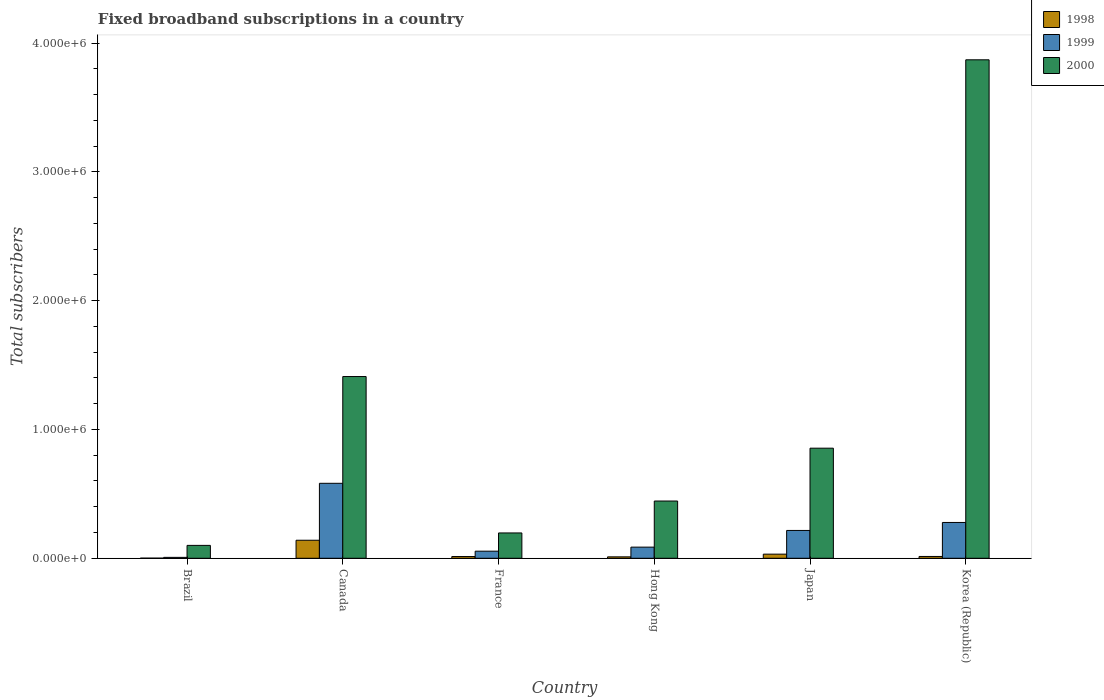How many different coloured bars are there?
Offer a terse response. 3. Are the number of bars per tick equal to the number of legend labels?
Provide a succinct answer. Yes. What is the label of the 1st group of bars from the left?
Offer a very short reply. Brazil. In how many cases, is the number of bars for a given country not equal to the number of legend labels?
Make the answer very short. 0. What is the number of broadband subscriptions in 2000 in Brazil?
Keep it short and to the point. 1.00e+05. Across all countries, what is the maximum number of broadband subscriptions in 1998?
Ensure brevity in your answer.  1.40e+05. What is the total number of broadband subscriptions in 2000 in the graph?
Make the answer very short. 6.88e+06. What is the difference between the number of broadband subscriptions in 1998 in Hong Kong and that in Korea (Republic)?
Your response must be concise. -3000. What is the difference between the number of broadband subscriptions in 2000 in Brazil and the number of broadband subscriptions in 1998 in Hong Kong?
Your answer should be compact. 8.90e+04. What is the average number of broadband subscriptions in 1998 per country?
Provide a short and direct response. 3.52e+04. What is the difference between the number of broadband subscriptions of/in 1999 and number of broadband subscriptions of/in 2000 in Brazil?
Keep it short and to the point. -9.30e+04. What is the ratio of the number of broadband subscriptions in 1998 in Canada to that in France?
Provide a succinct answer. 10.4. Is the number of broadband subscriptions in 1999 in Brazil less than that in Korea (Republic)?
Give a very brief answer. Yes. Is the difference between the number of broadband subscriptions in 1999 in Brazil and Korea (Republic) greater than the difference between the number of broadband subscriptions in 2000 in Brazil and Korea (Republic)?
Offer a very short reply. Yes. What is the difference between the highest and the second highest number of broadband subscriptions in 2000?
Your answer should be compact. 2.46e+06. What is the difference between the highest and the lowest number of broadband subscriptions in 1998?
Provide a succinct answer. 1.39e+05. In how many countries, is the number of broadband subscriptions in 1998 greater than the average number of broadband subscriptions in 1998 taken over all countries?
Your answer should be compact. 1. Is the sum of the number of broadband subscriptions in 1999 in France and Korea (Republic) greater than the maximum number of broadband subscriptions in 2000 across all countries?
Your answer should be compact. No. What does the 1st bar from the right in Japan represents?
Give a very brief answer. 2000. Are all the bars in the graph horizontal?
Give a very brief answer. No. How many countries are there in the graph?
Ensure brevity in your answer.  6. What is the difference between two consecutive major ticks on the Y-axis?
Your answer should be very brief. 1.00e+06. Where does the legend appear in the graph?
Your answer should be compact. Top right. How many legend labels are there?
Offer a very short reply. 3. How are the legend labels stacked?
Offer a terse response. Vertical. What is the title of the graph?
Offer a terse response. Fixed broadband subscriptions in a country. What is the label or title of the Y-axis?
Ensure brevity in your answer.  Total subscribers. What is the Total subscribers of 1998 in Brazil?
Give a very brief answer. 1000. What is the Total subscribers in 1999 in Brazil?
Your answer should be compact. 7000. What is the Total subscribers in 2000 in Brazil?
Provide a short and direct response. 1.00e+05. What is the Total subscribers of 1999 in Canada?
Ensure brevity in your answer.  5.82e+05. What is the Total subscribers of 2000 in Canada?
Keep it short and to the point. 1.41e+06. What is the Total subscribers in 1998 in France?
Ensure brevity in your answer.  1.35e+04. What is the Total subscribers of 1999 in France?
Your answer should be compact. 5.50e+04. What is the Total subscribers in 2000 in France?
Ensure brevity in your answer.  1.97e+05. What is the Total subscribers of 1998 in Hong Kong?
Ensure brevity in your answer.  1.10e+04. What is the Total subscribers of 1999 in Hong Kong?
Provide a succinct answer. 8.65e+04. What is the Total subscribers in 2000 in Hong Kong?
Provide a succinct answer. 4.44e+05. What is the Total subscribers in 1998 in Japan?
Ensure brevity in your answer.  3.20e+04. What is the Total subscribers in 1999 in Japan?
Your answer should be very brief. 2.16e+05. What is the Total subscribers of 2000 in Japan?
Provide a short and direct response. 8.55e+05. What is the Total subscribers of 1998 in Korea (Republic)?
Offer a terse response. 1.40e+04. What is the Total subscribers in 1999 in Korea (Republic)?
Give a very brief answer. 2.78e+05. What is the Total subscribers of 2000 in Korea (Republic)?
Your answer should be very brief. 3.87e+06. Across all countries, what is the maximum Total subscribers in 1998?
Your answer should be compact. 1.40e+05. Across all countries, what is the maximum Total subscribers of 1999?
Keep it short and to the point. 5.82e+05. Across all countries, what is the maximum Total subscribers of 2000?
Your response must be concise. 3.87e+06. Across all countries, what is the minimum Total subscribers in 1999?
Provide a short and direct response. 7000. What is the total Total subscribers in 1998 in the graph?
Your answer should be compact. 2.11e+05. What is the total Total subscribers in 1999 in the graph?
Your response must be concise. 1.22e+06. What is the total Total subscribers in 2000 in the graph?
Your answer should be compact. 6.88e+06. What is the difference between the Total subscribers in 1998 in Brazil and that in Canada?
Keep it short and to the point. -1.39e+05. What is the difference between the Total subscribers in 1999 in Brazil and that in Canada?
Ensure brevity in your answer.  -5.75e+05. What is the difference between the Total subscribers of 2000 in Brazil and that in Canada?
Offer a terse response. -1.31e+06. What is the difference between the Total subscribers in 1998 in Brazil and that in France?
Provide a short and direct response. -1.25e+04. What is the difference between the Total subscribers of 1999 in Brazil and that in France?
Provide a short and direct response. -4.80e+04. What is the difference between the Total subscribers of 2000 in Brazil and that in France?
Give a very brief answer. -9.66e+04. What is the difference between the Total subscribers in 1999 in Brazil and that in Hong Kong?
Offer a terse response. -7.95e+04. What is the difference between the Total subscribers in 2000 in Brazil and that in Hong Kong?
Offer a very short reply. -3.44e+05. What is the difference between the Total subscribers in 1998 in Brazil and that in Japan?
Provide a succinct answer. -3.10e+04. What is the difference between the Total subscribers in 1999 in Brazil and that in Japan?
Keep it short and to the point. -2.09e+05. What is the difference between the Total subscribers of 2000 in Brazil and that in Japan?
Your response must be concise. -7.55e+05. What is the difference between the Total subscribers of 1998 in Brazil and that in Korea (Republic)?
Give a very brief answer. -1.30e+04. What is the difference between the Total subscribers in 1999 in Brazil and that in Korea (Republic)?
Your response must be concise. -2.71e+05. What is the difference between the Total subscribers of 2000 in Brazil and that in Korea (Republic)?
Your response must be concise. -3.77e+06. What is the difference between the Total subscribers of 1998 in Canada and that in France?
Your answer should be compact. 1.27e+05. What is the difference between the Total subscribers of 1999 in Canada and that in France?
Offer a terse response. 5.27e+05. What is the difference between the Total subscribers in 2000 in Canada and that in France?
Give a very brief answer. 1.21e+06. What is the difference between the Total subscribers in 1998 in Canada and that in Hong Kong?
Your answer should be very brief. 1.29e+05. What is the difference between the Total subscribers in 1999 in Canada and that in Hong Kong?
Your response must be concise. 4.96e+05. What is the difference between the Total subscribers of 2000 in Canada and that in Hong Kong?
Keep it short and to the point. 9.66e+05. What is the difference between the Total subscribers in 1998 in Canada and that in Japan?
Your response must be concise. 1.08e+05. What is the difference between the Total subscribers of 1999 in Canada and that in Japan?
Provide a short and direct response. 3.66e+05. What is the difference between the Total subscribers of 2000 in Canada and that in Japan?
Ensure brevity in your answer.  5.56e+05. What is the difference between the Total subscribers in 1998 in Canada and that in Korea (Republic)?
Provide a succinct answer. 1.26e+05. What is the difference between the Total subscribers in 1999 in Canada and that in Korea (Republic)?
Make the answer very short. 3.04e+05. What is the difference between the Total subscribers in 2000 in Canada and that in Korea (Republic)?
Provide a succinct answer. -2.46e+06. What is the difference between the Total subscribers in 1998 in France and that in Hong Kong?
Keep it short and to the point. 2464. What is the difference between the Total subscribers of 1999 in France and that in Hong Kong?
Your answer should be compact. -3.15e+04. What is the difference between the Total subscribers in 2000 in France and that in Hong Kong?
Provide a short and direct response. -2.48e+05. What is the difference between the Total subscribers in 1998 in France and that in Japan?
Your response must be concise. -1.85e+04. What is the difference between the Total subscribers of 1999 in France and that in Japan?
Your answer should be compact. -1.61e+05. What is the difference between the Total subscribers in 2000 in France and that in Japan?
Give a very brief answer. -6.58e+05. What is the difference between the Total subscribers of 1998 in France and that in Korea (Republic)?
Offer a terse response. -536. What is the difference between the Total subscribers of 1999 in France and that in Korea (Republic)?
Provide a short and direct response. -2.23e+05. What is the difference between the Total subscribers in 2000 in France and that in Korea (Republic)?
Give a very brief answer. -3.67e+06. What is the difference between the Total subscribers in 1998 in Hong Kong and that in Japan?
Offer a very short reply. -2.10e+04. What is the difference between the Total subscribers of 1999 in Hong Kong and that in Japan?
Your answer should be compact. -1.30e+05. What is the difference between the Total subscribers in 2000 in Hong Kong and that in Japan?
Ensure brevity in your answer.  -4.10e+05. What is the difference between the Total subscribers of 1998 in Hong Kong and that in Korea (Republic)?
Keep it short and to the point. -3000. What is the difference between the Total subscribers of 1999 in Hong Kong and that in Korea (Republic)?
Your answer should be very brief. -1.92e+05. What is the difference between the Total subscribers of 2000 in Hong Kong and that in Korea (Republic)?
Your answer should be compact. -3.43e+06. What is the difference between the Total subscribers of 1998 in Japan and that in Korea (Republic)?
Your answer should be compact. 1.80e+04. What is the difference between the Total subscribers in 1999 in Japan and that in Korea (Republic)?
Ensure brevity in your answer.  -6.20e+04. What is the difference between the Total subscribers in 2000 in Japan and that in Korea (Republic)?
Ensure brevity in your answer.  -3.02e+06. What is the difference between the Total subscribers in 1998 in Brazil and the Total subscribers in 1999 in Canada?
Ensure brevity in your answer.  -5.81e+05. What is the difference between the Total subscribers in 1998 in Brazil and the Total subscribers in 2000 in Canada?
Make the answer very short. -1.41e+06. What is the difference between the Total subscribers of 1999 in Brazil and the Total subscribers of 2000 in Canada?
Your response must be concise. -1.40e+06. What is the difference between the Total subscribers in 1998 in Brazil and the Total subscribers in 1999 in France?
Your answer should be very brief. -5.40e+04. What is the difference between the Total subscribers of 1998 in Brazil and the Total subscribers of 2000 in France?
Your answer should be very brief. -1.96e+05. What is the difference between the Total subscribers in 1999 in Brazil and the Total subscribers in 2000 in France?
Offer a very short reply. -1.90e+05. What is the difference between the Total subscribers in 1998 in Brazil and the Total subscribers in 1999 in Hong Kong?
Keep it short and to the point. -8.55e+04. What is the difference between the Total subscribers of 1998 in Brazil and the Total subscribers of 2000 in Hong Kong?
Offer a very short reply. -4.43e+05. What is the difference between the Total subscribers in 1999 in Brazil and the Total subscribers in 2000 in Hong Kong?
Your answer should be compact. -4.37e+05. What is the difference between the Total subscribers of 1998 in Brazil and the Total subscribers of 1999 in Japan?
Ensure brevity in your answer.  -2.15e+05. What is the difference between the Total subscribers of 1998 in Brazil and the Total subscribers of 2000 in Japan?
Offer a terse response. -8.54e+05. What is the difference between the Total subscribers of 1999 in Brazil and the Total subscribers of 2000 in Japan?
Provide a short and direct response. -8.48e+05. What is the difference between the Total subscribers of 1998 in Brazil and the Total subscribers of 1999 in Korea (Republic)?
Make the answer very short. -2.77e+05. What is the difference between the Total subscribers in 1998 in Brazil and the Total subscribers in 2000 in Korea (Republic)?
Make the answer very short. -3.87e+06. What is the difference between the Total subscribers of 1999 in Brazil and the Total subscribers of 2000 in Korea (Republic)?
Offer a terse response. -3.86e+06. What is the difference between the Total subscribers in 1998 in Canada and the Total subscribers in 1999 in France?
Offer a very short reply. 8.50e+04. What is the difference between the Total subscribers in 1998 in Canada and the Total subscribers in 2000 in France?
Your response must be concise. -5.66e+04. What is the difference between the Total subscribers of 1999 in Canada and the Total subscribers of 2000 in France?
Offer a very short reply. 3.85e+05. What is the difference between the Total subscribers in 1998 in Canada and the Total subscribers in 1999 in Hong Kong?
Your answer should be compact. 5.35e+04. What is the difference between the Total subscribers in 1998 in Canada and the Total subscribers in 2000 in Hong Kong?
Your answer should be compact. -3.04e+05. What is the difference between the Total subscribers in 1999 in Canada and the Total subscribers in 2000 in Hong Kong?
Offer a very short reply. 1.38e+05. What is the difference between the Total subscribers in 1998 in Canada and the Total subscribers in 1999 in Japan?
Offer a very short reply. -7.60e+04. What is the difference between the Total subscribers of 1998 in Canada and the Total subscribers of 2000 in Japan?
Keep it short and to the point. -7.15e+05. What is the difference between the Total subscribers in 1999 in Canada and the Total subscribers in 2000 in Japan?
Provide a short and direct response. -2.73e+05. What is the difference between the Total subscribers in 1998 in Canada and the Total subscribers in 1999 in Korea (Republic)?
Offer a very short reply. -1.38e+05. What is the difference between the Total subscribers of 1998 in Canada and the Total subscribers of 2000 in Korea (Republic)?
Provide a succinct answer. -3.73e+06. What is the difference between the Total subscribers of 1999 in Canada and the Total subscribers of 2000 in Korea (Republic)?
Provide a succinct answer. -3.29e+06. What is the difference between the Total subscribers in 1998 in France and the Total subscribers in 1999 in Hong Kong?
Ensure brevity in your answer.  -7.30e+04. What is the difference between the Total subscribers of 1998 in France and the Total subscribers of 2000 in Hong Kong?
Give a very brief answer. -4.31e+05. What is the difference between the Total subscribers of 1999 in France and the Total subscribers of 2000 in Hong Kong?
Give a very brief answer. -3.89e+05. What is the difference between the Total subscribers in 1998 in France and the Total subscribers in 1999 in Japan?
Offer a very short reply. -2.03e+05. What is the difference between the Total subscribers in 1998 in France and the Total subscribers in 2000 in Japan?
Keep it short and to the point. -8.41e+05. What is the difference between the Total subscribers of 1999 in France and the Total subscribers of 2000 in Japan?
Provide a short and direct response. -8.00e+05. What is the difference between the Total subscribers in 1998 in France and the Total subscribers in 1999 in Korea (Republic)?
Your response must be concise. -2.65e+05. What is the difference between the Total subscribers of 1998 in France and the Total subscribers of 2000 in Korea (Republic)?
Make the answer very short. -3.86e+06. What is the difference between the Total subscribers of 1999 in France and the Total subscribers of 2000 in Korea (Republic)?
Offer a very short reply. -3.82e+06. What is the difference between the Total subscribers of 1998 in Hong Kong and the Total subscribers of 1999 in Japan?
Offer a very short reply. -2.05e+05. What is the difference between the Total subscribers in 1998 in Hong Kong and the Total subscribers in 2000 in Japan?
Provide a succinct answer. -8.44e+05. What is the difference between the Total subscribers in 1999 in Hong Kong and the Total subscribers in 2000 in Japan?
Make the answer very short. -7.68e+05. What is the difference between the Total subscribers in 1998 in Hong Kong and the Total subscribers in 1999 in Korea (Republic)?
Make the answer very short. -2.67e+05. What is the difference between the Total subscribers in 1998 in Hong Kong and the Total subscribers in 2000 in Korea (Republic)?
Give a very brief answer. -3.86e+06. What is the difference between the Total subscribers in 1999 in Hong Kong and the Total subscribers in 2000 in Korea (Republic)?
Your response must be concise. -3.78e+06. What is the difference between the Total subscribers in 1998 in Japan and the Total subscribers in 1999 in Korea (Republic)?
Keep it short and to the point. -2.46e+05. What is the difference between the Total subscribers of 1998 in Japan and the Total subscribers of 2000 in Korea (Republic)?
Keep it short and to the point. -3.84e+06. What is the difference between the Total subscribers in 1999 in Japan and the Total subscribers in 2000 in Korea (Republic)?
Keep it short and to the point. -3.65e+06. What is the average Total subscribers in 1998 per country?
Offer a very short reply. 3.52e+04. What is the average Total subscribers of 1999 per country?
Provide a succinct answer. 2.04e+05. What is the average Total subscribers in 2000 per country?
Offer a terse response. 1.15e+06. What is the difference between the Total subscribers in 1998 and Total subscribers in 1999 in Brazil?
Ensure brevity in your answer.  -6000. What is the difference between the Total subscribers of 1998 and Total subscribers of 2000 in Brazil?
Keep it short and to the point. -9.90e+04. What is the difference between the Total subscribers of 1999 and Total subscribers of 2000 in Brazil?
Ensure brevity in your answer.  -9.30e+04. What is the difference between the Total subscribers of 1998 and Total subscribers of 1999 in Canada?
Provide a short and direct response. -4.42e+05. What is the difference between the Total subscribers of 1998 and Total subscribers of 2000 in Canada?
Keep it short and to the point. -1.27e+06. What is the difference between the Total subscribers of 1999 and Total subscribers of 2000 in Canada?
Offer a very short reply. -8.29e+05. What is the difference between the Total subscribers of 1998 and Total subscribers of 1999 in France?
Provide a succinct answer. -4.15e+04. What is the difference between the Total subscribers in 1998 and Total subscribers in 2000 in France?
Give a very brief answer. -1.83e+05. What is the difference between the Total subscribers of 1999 and Total subscribers of 2000 in France?
Provide a short and direct response. -1.42e+05. What is the difference between the Total subscribers of 1998 and Total subscribers of 1999 in Hong Kong?
Provide a short and direct response. -7.55e+04. What is the difference between the Total subscribers in 1998 and Total subscribers in 2000 in Hong Kong?
Your answer should be very brief. -4.33e+05. What is the difference between the Total subscribers of 1999 and Total subscribers of 2000 in Hong Kong?
Make the answer very short. -3.58e+05. What is the difference between the Total subscribers of 1998 and Total subscribers of 1999 in Japan?
Ensure brevity in your answer.  -1.84e+05. What is the difference between the Total subscribers in 1998 and Total subscribers in 2000 in Japan?
Give a very brief answer. -8.23e+05. What is the difference between the Total subscribers in 1999 and Total subscribers in 2000 in Japan?
Ensure brevity in your answer.  -6.39e+05. What is the difference between the Total subscribers in 1998 and Total subscribers in 1999 in Korea (Republic)?
Make the answer very short. -2.64e+05. What is the difference between the Total subscribers of 1998 and Total subscribers of 2000 in Korea (Republic)?
Your answer should be compact. -3.86e+06. What is the difference between the Total subscribers of 1999 and Total subscribers of 2000 in Korea (Republic)?
Your answer should be compact. -3.59e+06. What is the ratio of the Total subscribers of 1998 in Brazil to that in Canada?
Your answer should be very brief. 0.01. What is the ratio of the Total subscribers of 1999 in Brazil to that in Canada?
Offer a terse response. 0.01. What is the ratio of the Total subscribers of 2000 in Brazil to that in Canada?
Your answer should be very brief. 0.07. What is the ratio of the Total subscribers of 1998 in Brazil to that in France?
Ensure brevity in your answer.  0.07. What is the ratio of the Total subscribers in 1999 in Brazil to that in France?
Give a very brief answer. 0.13. What is the ratio of the Total subscribers in 2000 in Brazil to that in France?
Provide a short and direct response. 0.51. What is the ratio of the Total subscribers of 1998 in Brazil to that in Hong Kong?
Make the answer very short. 0.09. What is the ratio of the Total subscribers in 1999 in Brazil to that in Hong Kong?
Ensure brevity in your answer.  0.08. What is the ratio of the Total subscribers in 2000 in Brazil to that in Hong Kong?
Offer a very short reply. 0.23. What is the ratio of the Total subscribers of 1998 in Brazil to that in Japan?
Your response must be concise. 0.03. What is the ratio of the Total subscribers of 1999 in Brazil to that in Japan?
Your answer should be very brief. 0.03. What is the ratio of the Total subscribers of 2000 in Brazil to that in Japan?
Provide a short and direct response. 0.12. What is the ratio of the Total subscribers in 1998 in Brazil to that in Korea (Republic)?
Ensure brevity in your answer.  0.07. What is the ratio of the Total subscribers in 1999 in Brazil to that in Korea (Republic)?
Provide a succinct answer. 0.03. What is the ratio of the Total subscribers of 2000 in Brazil to that in Korea (Republic)?
Your answer should be compact. 0.03. What is the ratio of the Total subscribers in 1998 in Canada to that in France?
Offer a terse response. 10.4. What is the ratio of the Total subscribers in 1999 in Canada to that in France?
Offer a very short reply. 10.58. What is the ratio of the Total subscribers of 2000 in Canada to that in France?
Give a very brief answer. 7.18. What is the ratio of the Total subscribers of 1998 in Canada to that in Hong Kong?
Offer a terse response. 12.73. What is the ratio of the Total subscribers of 1999 in Canada to that in Hong Kong?
Your answer should be very brief. 6.73. What is the ratio of the Total subscribers of 2000 in Canada to that in Hong Kong?
Your answer should be very brief. 3.17. What is the ratio of the Total subscribers of 1998 in Canada to that in Japan?
Provide a short and direct response. 4.38. What is the ratio of the Total subscribers of 1999 in Canada to that in Japan?
Provide a short and direct response. 2.69. What is the ratio of the Total subscribers in 2000 in Canada to that in Japan?
Ensure brevity in your answer.  1.65. What is the ratio of the Total subscribers of 1999 in Canada to that in Korea (Republic)?
Your answer should be very brief. 2.09. What is the ratio of the Total subscribers of 2000 in Canada to that in Korea (Republic)?
Provide a short and direct response. 0.36. What is the ratio of the Total subscribers in 1998 in France to that in Hong Kong?
Offer a terse response. 1.22. What is the ratio of the Total subscribers of 1999 in France to that in Hong Kong?
Make the answer very short. 0.64. What is the ratio of the Total subscribers in 2000 in France to that in Hong Kong?
Make the answer very short. 0.44. What is the ratio of the Total subscribers in 1998 in France to that in Japan?
Your response must be concise. 0.42. What is the ratio of the Total subscribers of 1999 in France to that in Japan?
Provide a short and direct response. 0.25. What is the ratio of the Total subscribers in 2000 in France to that in Japan?
Provide a succinct answer. 0.23. What is the ratio of the Total subscribers of 1998 in France to that in Korea (Republic)?
Give a very brief answer. 0.96. What is the ratio of the Total subscribers of 1999 in France to that in Korea (Republic)?
Offer a terse response. 0.2. What is the ratio of the Total subscribers of 2000 in France to that in Korea (Republic)?
Give a very brief answer. 0.05. What is the ratio of the Total subscribers of 1998 in Hong Kong to that in Japan?
Offer a terse response. 0.34. What is the ratio of the Total subscribers in 1999 in Hong Kong to that in Japan?
Your response must be concise. 0.4. What is the ratio of the Total subscribers in 2000 in Hong Kong to that in Japan?
Give a very brief answer. 0.52. What is the ratio of the Total subscribers of 1998 in Hong Kong to that in Korea (Republic)?
Make the answer very short. 0.79. What is the ratio of the Total subscribers of 1999 in Hong Kong to that in Korea (Republic)?
Provide a succinct answer. 0.31. What is the ratio of the Total subscribers of 2000 in Hong Kong to that in Korea (Republic)?
Offer a terse response. 0.11. What is the ratio of the Total subscribers of 1998 in Japan to that in Korea (Republic)?
Keep it short and to the point. 2.29. What is the ratio of the Total subscribers in 1999 in Japan to that in Korea (Republic)?
Your answer should be very brief. 0.78. What is the ratio of the Total subscribers of 2000 in Japan to that in Korea (Republic)?
Make the answer very short. 0.22. What is the difference between the highest and the second highest Total subscribers in 1998?
Give a very brief answer. 1.08e+05. What is the difference between the highest and the second highest Total subscribers of 1999?
Your answer should be very brief. 3.04e+05. What is the difference between the highest and the second highest Total subscribers in 2000?
Provide a short and direct response. 2.46e+06. What is the difference between the highest and the lowest Total subscribers in 1998?
Offer a terse response. 1.39e+05. What is the difference between the highest and the lowest Total subscribers in 1999?
Offer a very short reply. 5.75e+05. What is the difference between the highest and the lowest Total subscribers in 2000?
Your answer should be compact. 3.77e+06. 